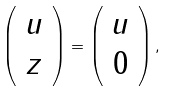<formula> <loc_0><loc_0><loc_500><loc_500>\left ( \begin{array} { c } u \\ z \end{array} \right ) = \left ( \begin{array} { c } u \\ 0 \end{array} \right ) ,</formula> 